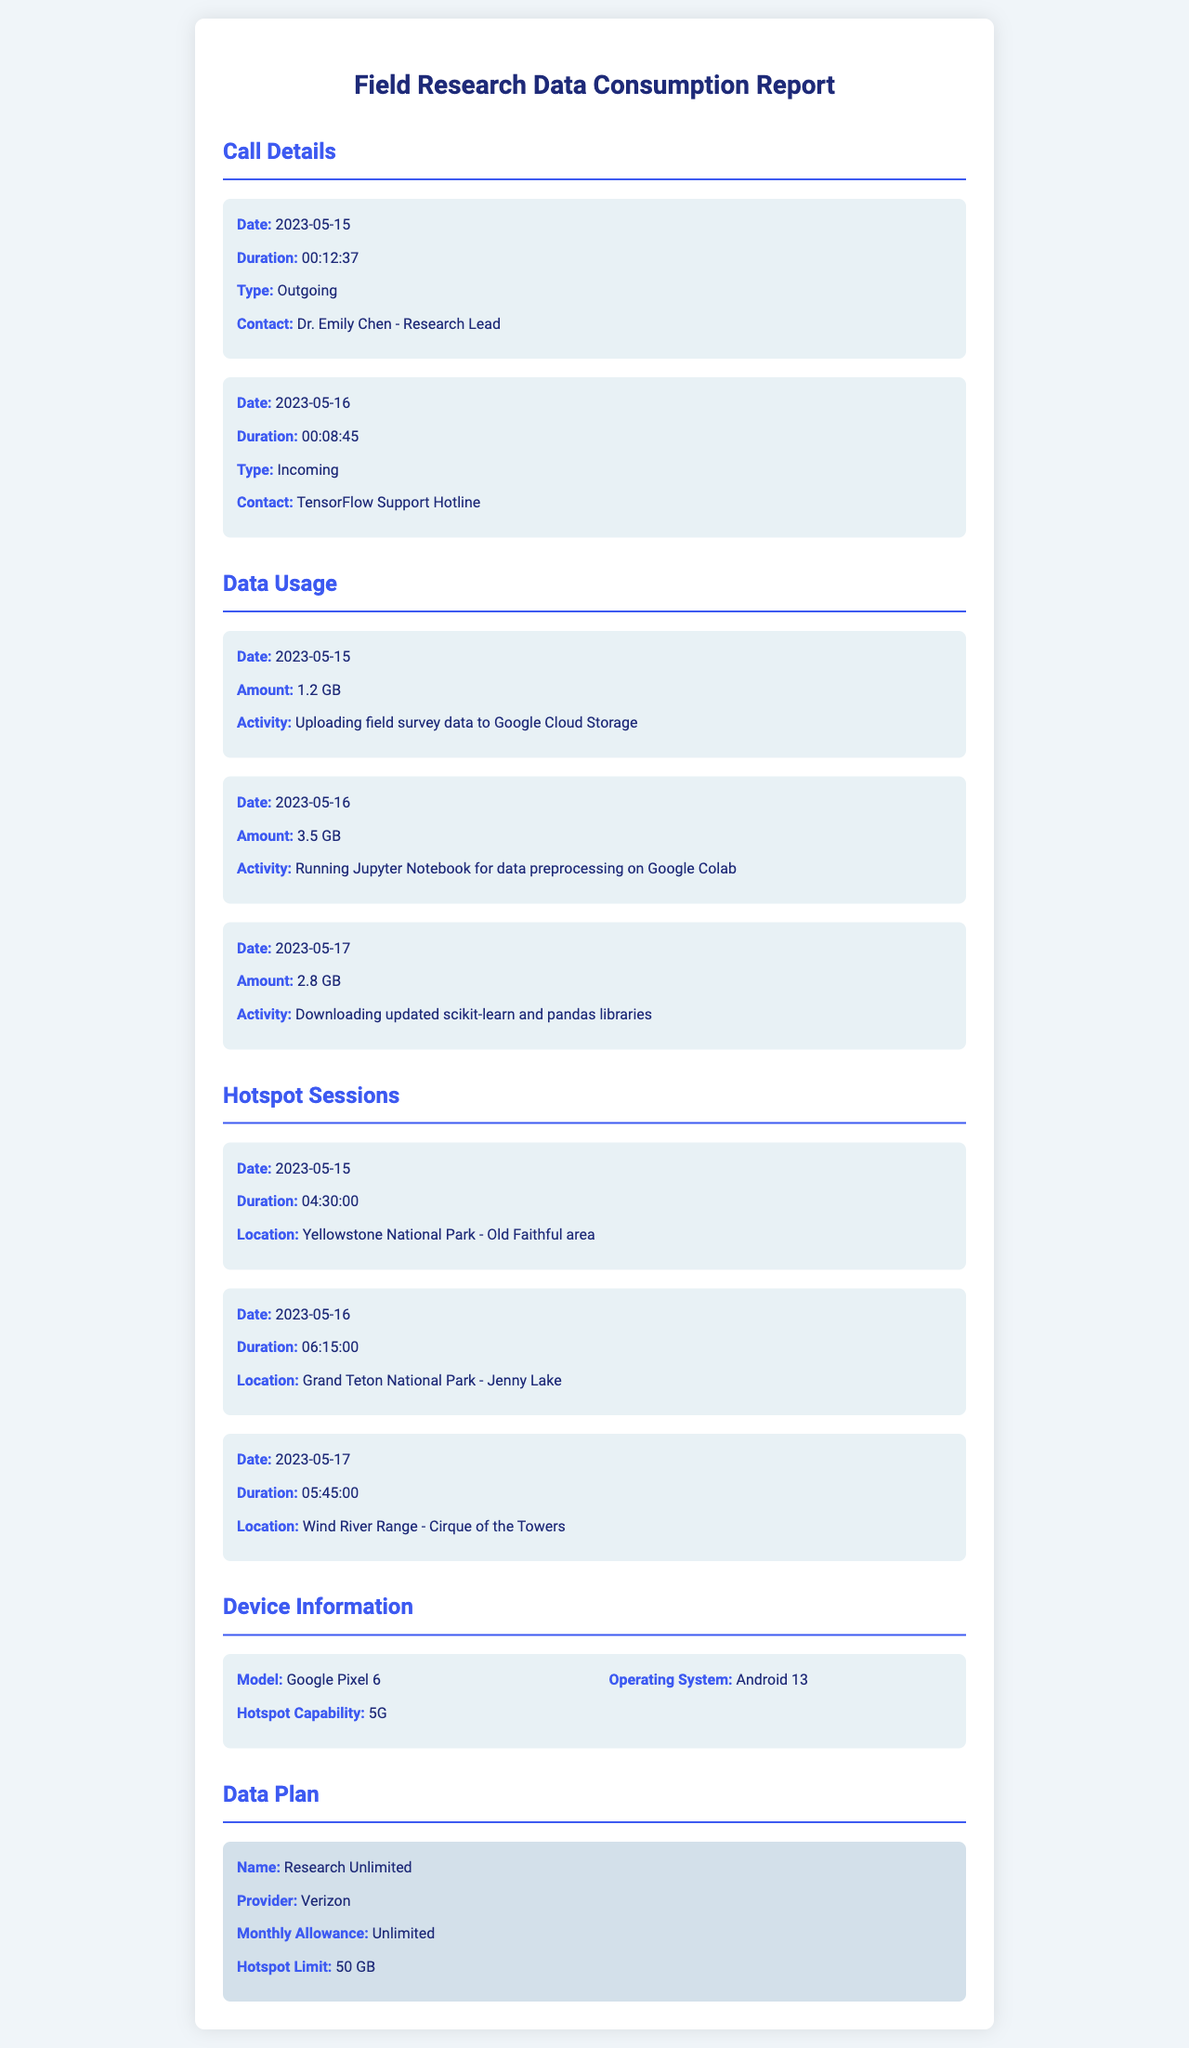what is the date of the first call? The first call recorded is on 2023-05-15.
Answer: 2023-05-15 how long was the call with Dr. Emily Chen? The duration of the call with Dr. Emily Chen is detailed as 00:12:37.
Answer: 00:12:37 what was the data usage on May 16? The document states that on May 16, 3.5 GB of data was used for running Jupyter Notebook.
Answer: 3.5 GB which location had the longest hotspot session? The hotspot session on 2023-05-16 at Grand Teton National Park lasted the longest at 06:15:00.
Answer: Grand Teton National Park - Jenny Lake what is the operating system of the device used? The document indicates the operating system of the device as Android 13.
Answer: Android 13 how much data is allowed for hotspot usage in the plan? The hotspot plan allows a limit of 50 GB for hotspot usage.
Answer: 50 GB what activity consumed 1.2 GB of data? The activity that consumed 1.2 GB on May 15 was uploading field survey data to Google Cloud Storage.
Answer: Uploading field survey data to Google Cloud Storage how long was the hotspot session on May 17? The document lists the duration of the hotspot session on May 17 as 05:45:00.
Answer: 05:45:00 who provided support on May 16? The support on May 16 was provided by the TensorFlow Support Hotline.
Answer: TensorFlow Support Hotline 